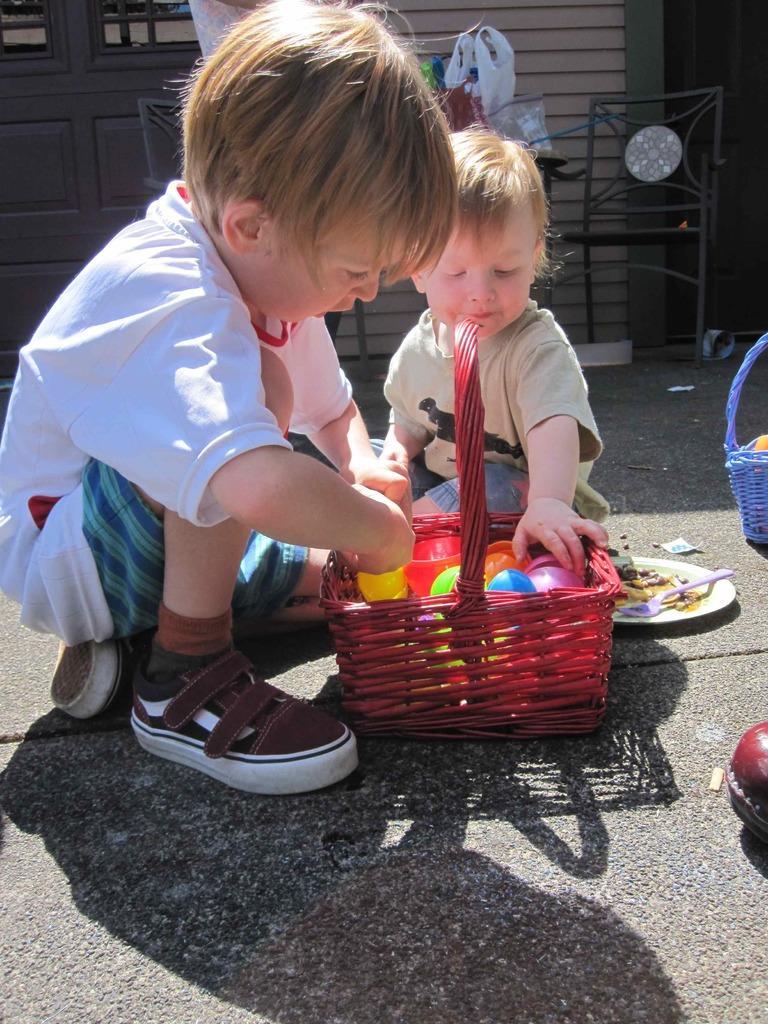Describe this image in one or two sentences. In the foreground of the picture there are two kids, balls, plate, baskets, toys, spoon and road. In the background there are chairs, doors, wall, cover, table and other objects. 